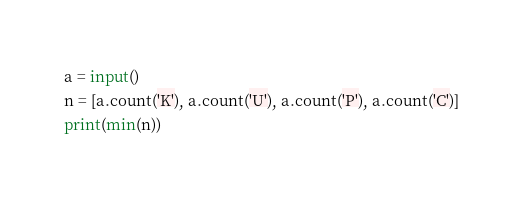<code> <loc_0><loc_0><loc_500><loc_500><_Python_>a = input()
n = [a.count('K'), a.count('U'), a.count('P'), a.count('C')]
print(min(n))
</code> 